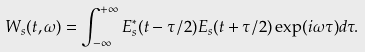<formula> <loc_0><loc_0><loc_500><loc_500>W _ { s } ( t , \omega ) = \int _ { - \infty } ^ { + \infty } E _ { s } ^ { \ast } ( t - \tau / 2 ) E _ { s } ( t + \tau / 2 ) \exp ( i \omega \tau ) d \tau .</formula> 